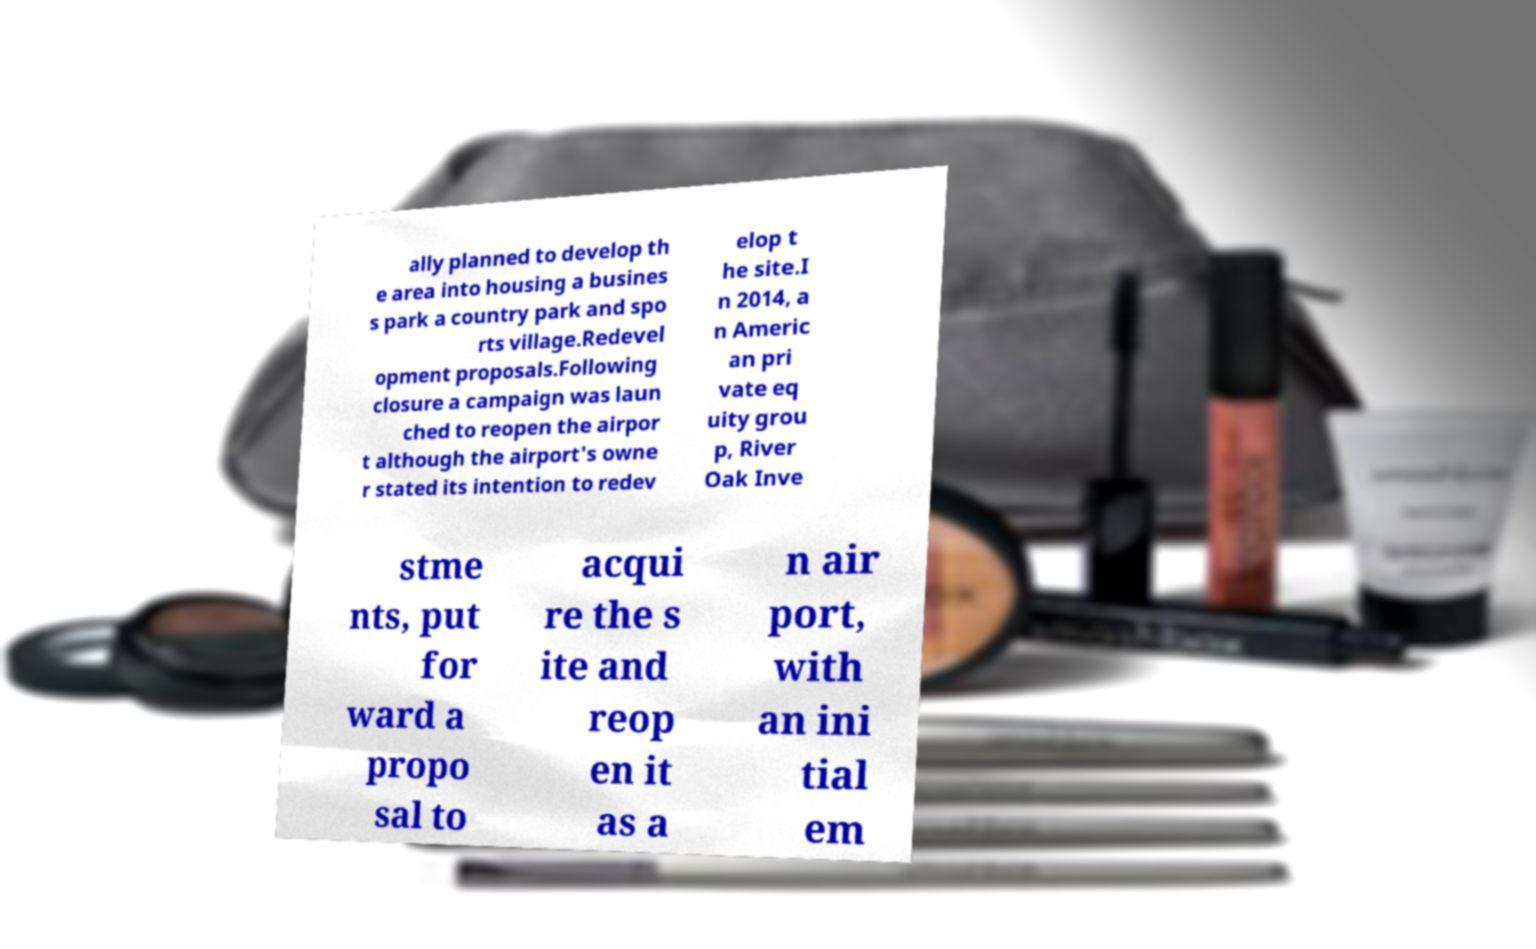For documentation purposes, I need the text within this image transcribed. Could you provide that? ally planned to develop th e area into housing a busines s park a country park and spo rts village.Redevel opment proposals.Following closure a campaign was laun ched to reopen the airpor t although the airport's owne r stated its intention to redev elop t he site.I n 2014, a n Americ an pri vate eq uity grou p, River Oak Inve stme nts, put for ward a propo sal to acqui re the s ite and reop en it as a n air port, with an ini tial em 